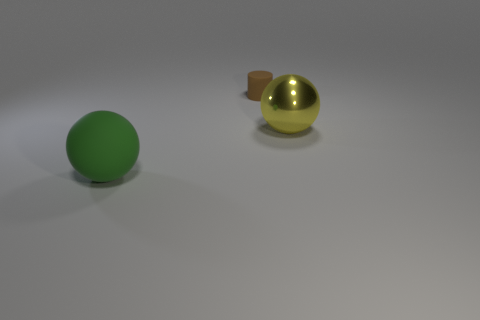Add 2 small gray metallic objects. How many objects exist? 5 Subtract all spheres. How many objects are left? 1 Add 1 metal things. How many metal things are left? 2 Add 3 large metallic objects. How many large metallic objects exist? 4 Subtract 0 cyan spheres. How many objects are left? 3 Subtract 1 spheres. How many spheres are left? 1 Subtract all cyan cylinders. Subtract all gray cubes. How many cylinders are left? 1 Subtract all brown cylinders. How many yellow balls are left? 1 Subtract all big yellow spheres. Subtract all metal spheres. How many objects are left? 1 